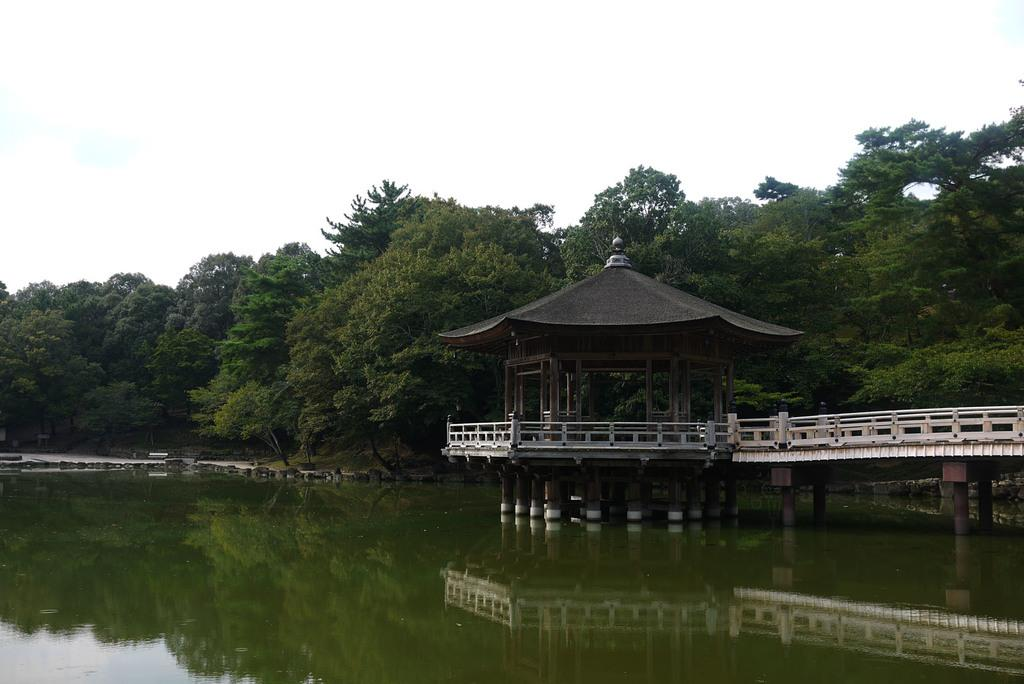What is the primary element visible in the image? There is water in the image. What structure can be seen crossing the water? There is a bridge in the image. What is located above the water and bridge? There is a roof top in the image. What can be seen in the distance behind the water and bridge? There are trees and the sky visible in the background of the image. Can you tell me how many plates are stacked on the donkey in the image? There is no donkey or plates present in the image. 